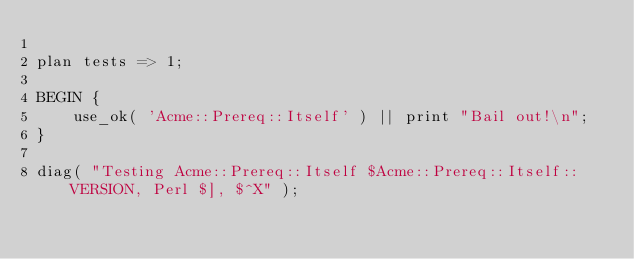Convert code to text. <code><loc_0><loc_0><loc_500><loc_500><_Perl_>
plan tests => 1;

BEGIN {
    use_ok( 'Acme::Prereq::Itself' ) || print "Bail out!\n";
}

diag( "Testing Acme::Prereq::Itself $Acme::Prereq::Itself::VERSION, Perl $], $^X" );
</code> 